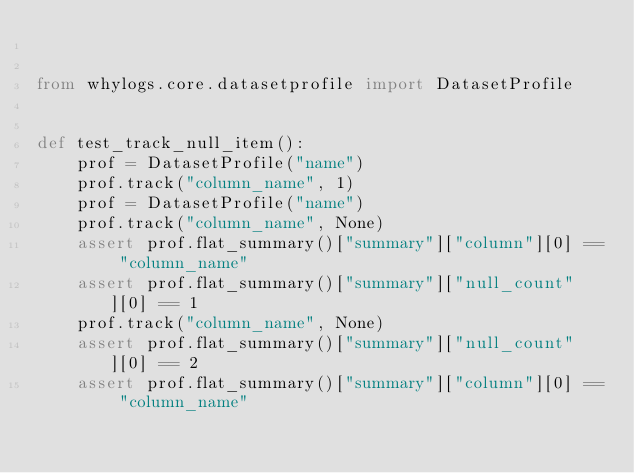<code> <loc_0><loc_0><loc_500><loc_500><_Python_>

from whylogs.core.datasetprofile import DatasetProfile


def test_track_null_item():
    prof = DatasetProfile("name")
    prof.track("column_name", 1)
    prof = DatasetProfile("name")
    prof.track("column_name", None)
    assert prof.flat_summary()["summary"]["column"][0] == "column_name"
    assert prof.flat_summary()["summary"]["null_count"][0] == 1
    prof.track("column_name", None)
    assert prof.flat_summary()["summary"]["null_count"][0] == 2
    assert prof.flat_summary()["summary"]["column"][0] == "column_name"
</code> 